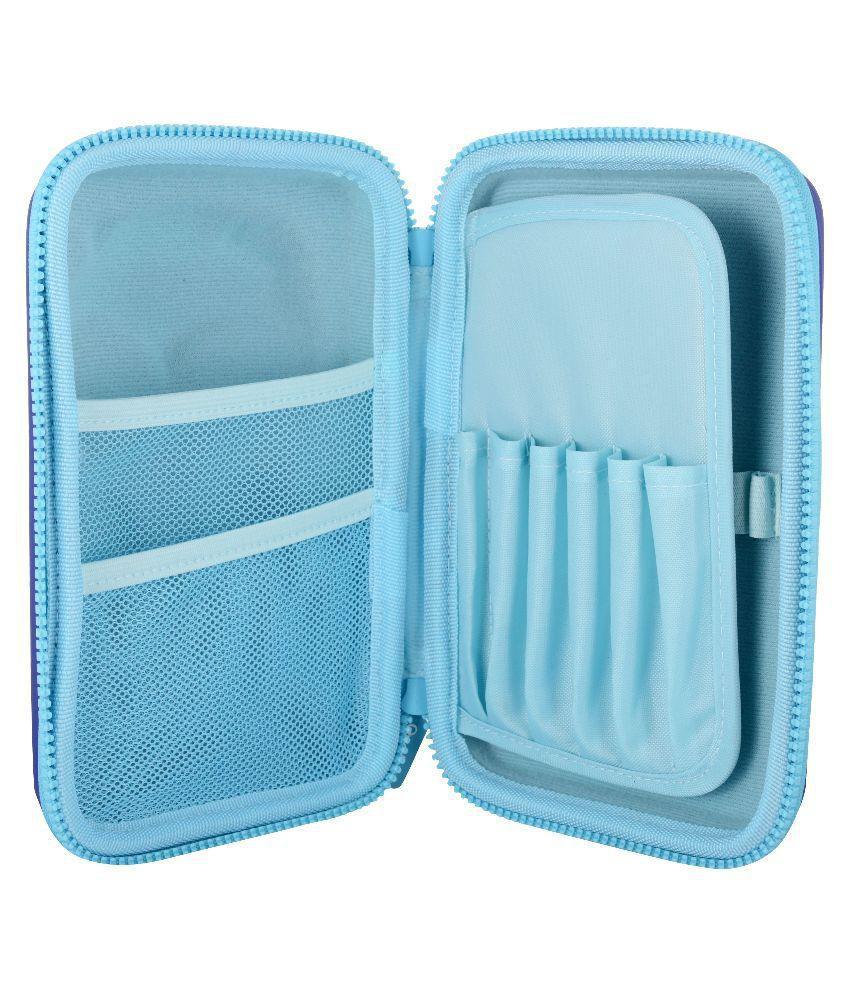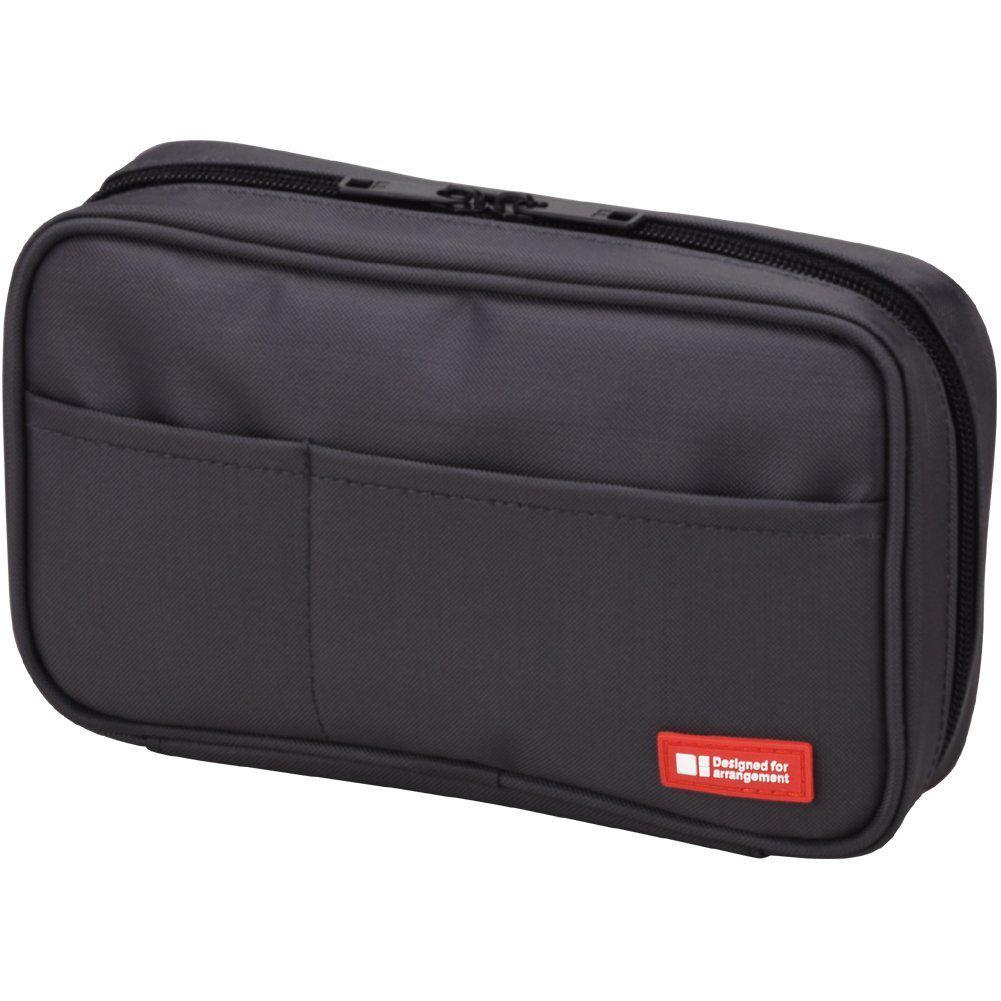The first image is the image on the left, the second image is the image on the right. For the images displayed, is the sentence "Atleast one item is light blue" factually correct? Answer yes or no. Yes. 